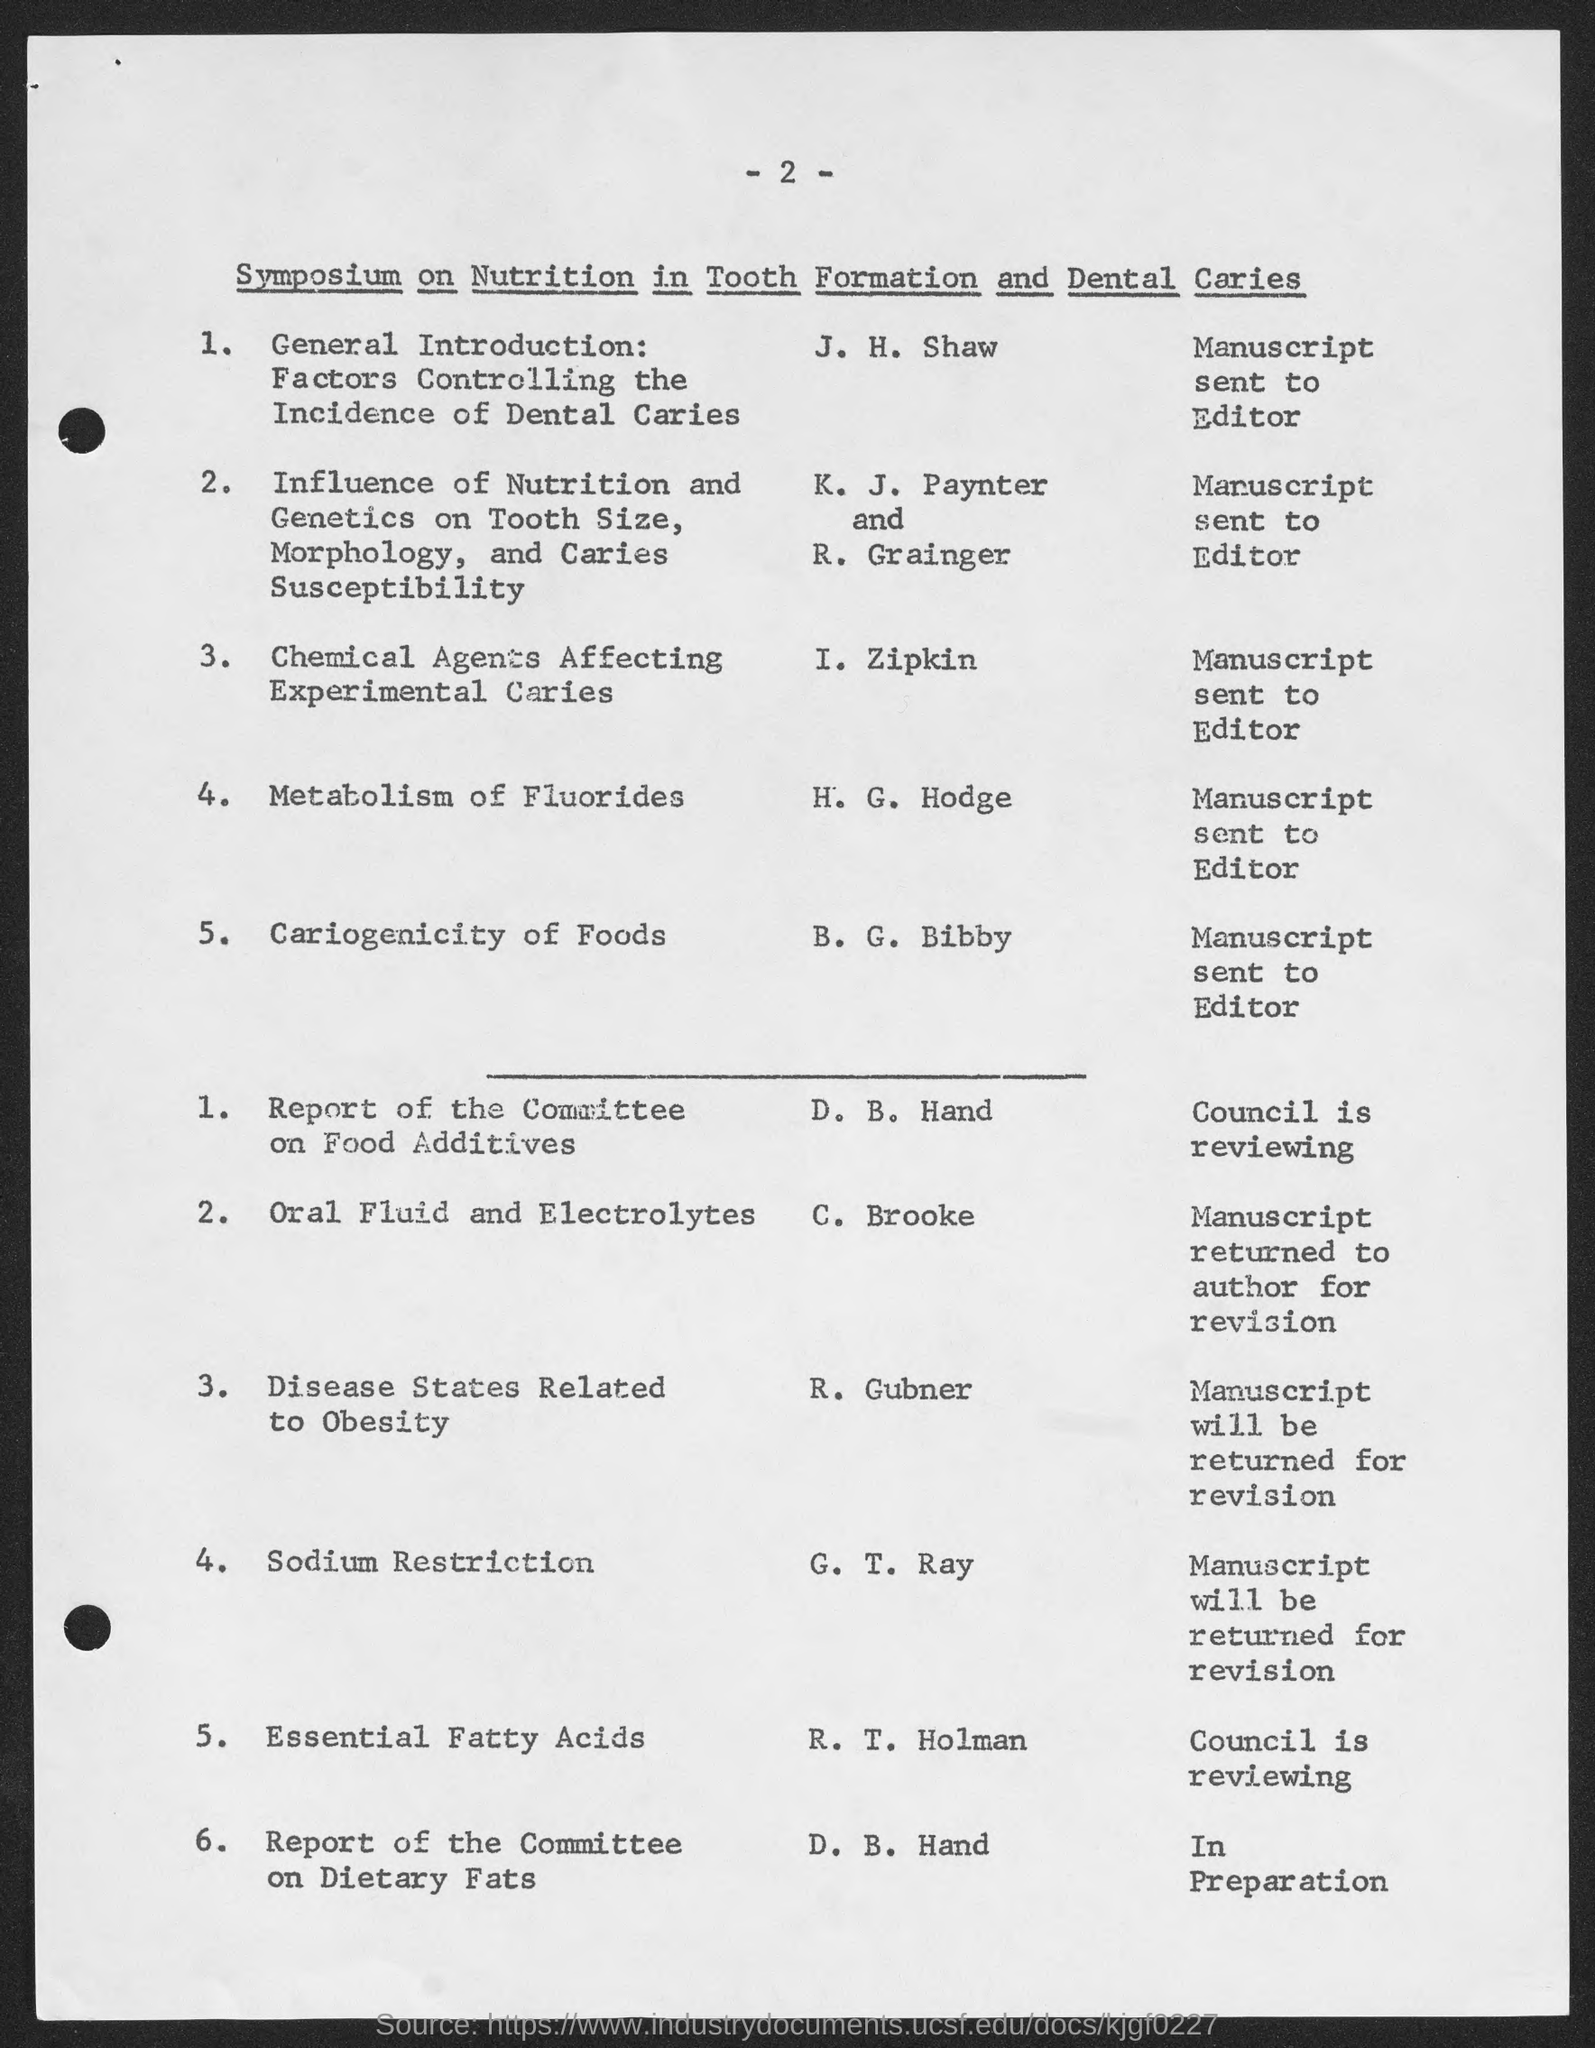Mention a couple of crucial points in this snapshot. The number at the top of the page is 2. 